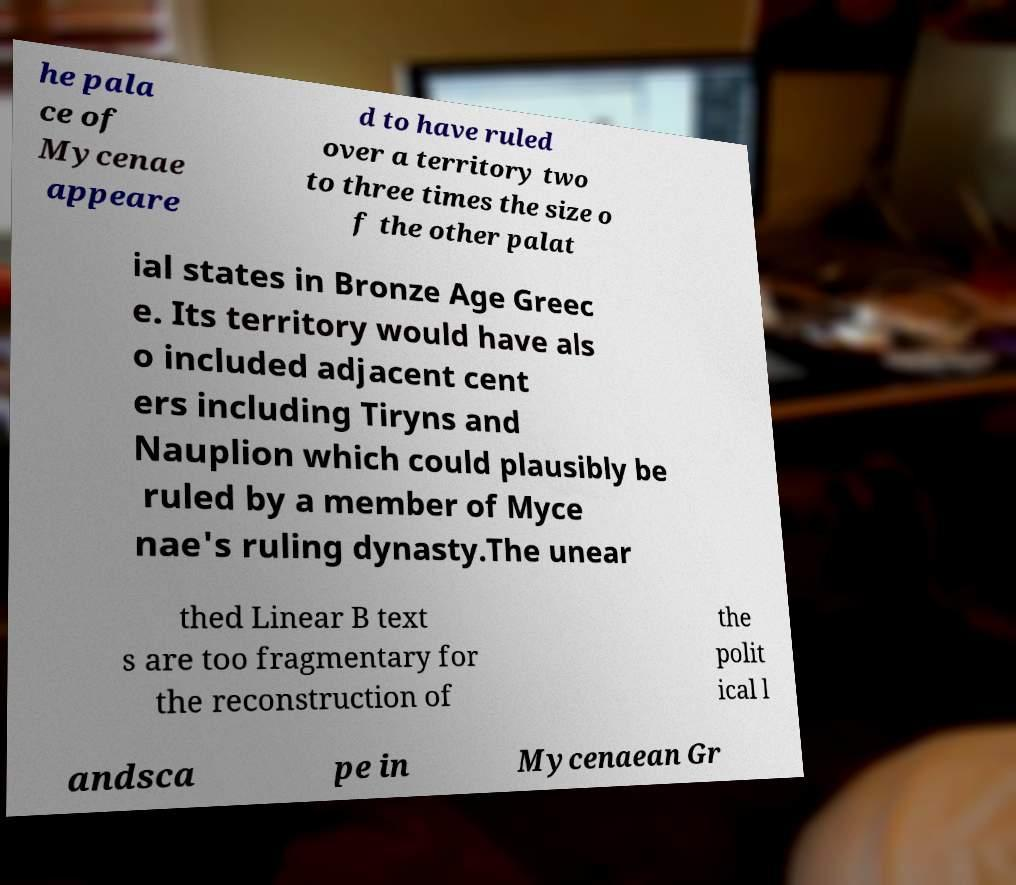For documentation purposes, I need the text within this image transcribed. Could you provide that? he pala ce of Mycenae appeare d to have ruled over a territory two to three times the size o f the other palat ial states in Bronze Age Greec e. Its territory would have als o included adjacent cent ers including Tiryns and Nauplion which could plausibly be ruled by a member of Myce nae's ruling dynasty.The unear thed Linear B text s are too fragmentary for the reconstruction of the polit ical l andsca pe in Mycenaean Gr 